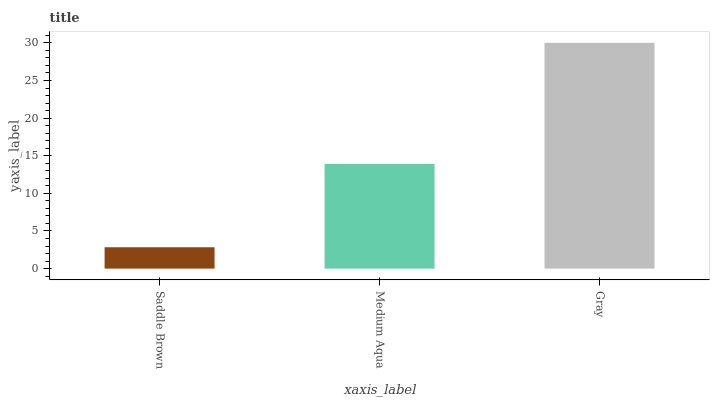Is Saddle Brown the minimum?
Answer yes or no. Yes. Is Gray the maximum?
Answer yes or no. Yes. Is Medium Aqua the minimum?
Answer yes or no. No. Is Medium Aqua the maximum?
Answer yes or no. No. Is Medium Aqua greater than Saddle Brown?
Answer yes or no. Yes. Is Saddle Brown less than Medium Aqua?
Answer yes or no. Yes. Is Saddle Brown greater than Medium Aqua?
Answer yes or no. No. Is Medium Aqua less than Saddle Brown?
Answer yes or no. No. Is Medium Aqua the high median?
Answer yes or no. Yes. Is Medium Aqua the low median?
Answer yes or no. Yes. Is Gray the high median?
Answer yes or no. No. Is Saddle Brown the low median?
Answer yes or no. No. 